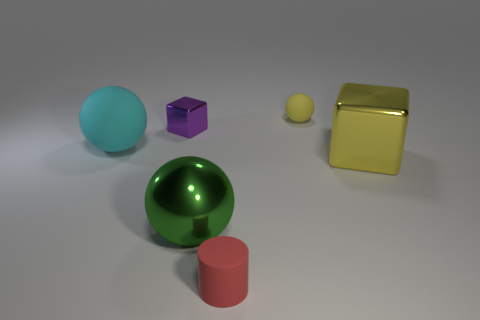Is the big green thing the same shape as the small yellow rubber thing?
Your answer should be compact. Yes. How many other things are there of the same shape as the yellow metallic thing?
Offer a very short reply. 1. There is a rubber ball that is the same size as the cylinder; what is its color?
Offer a terse response. Yellow. Is the number of tiny yellow things in front of the green metallic object the same as the number of large green balls?
Your response must be concise. No. The thing that is both in front of the small matte sphere and on the right side of the red rubber thing has what shape?
Ensure brevity in your answer.  Cube. Does the green shiny thing have the same size as the yellow rubber sphere?
Offer a very short reply. No. Is there a red cylinder that has the same material as the cyan sphere?
Your answer should be compact. Yes. There is a shiny object that is the same color as the small matte sphere; what is its size?
Your answer should be very brief. Large. How many spheres are both right of the matte cylinder and left of the large green shiny thing?
Provide a short and direct response. 0. There is a big thing that is to the right of the large green metallic thing; what is its material?
Keep it short and to the point. Metal. 